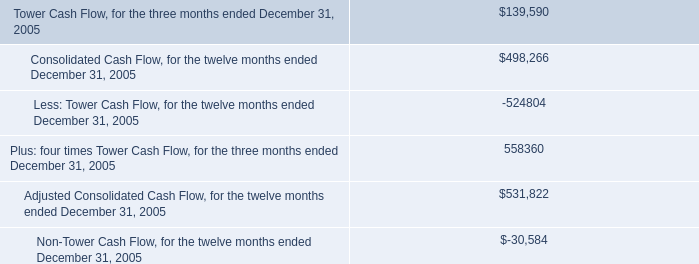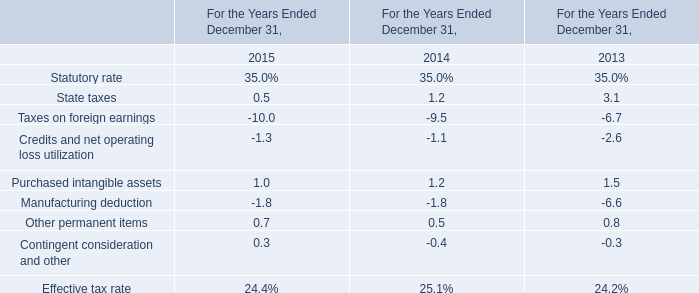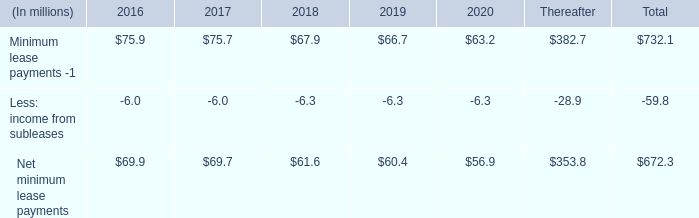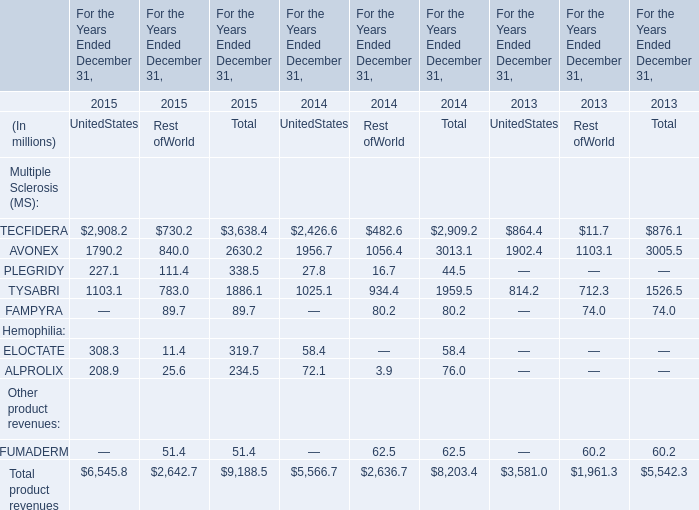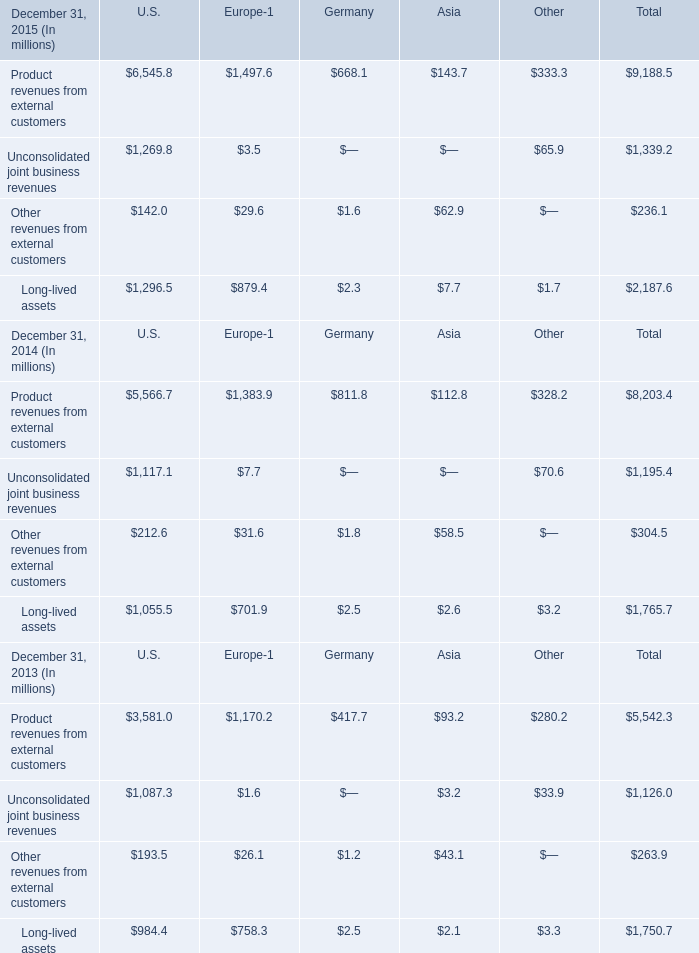How many element revenues exceed the average of AVONEX in 2015 in total? 
Answer: 7. 